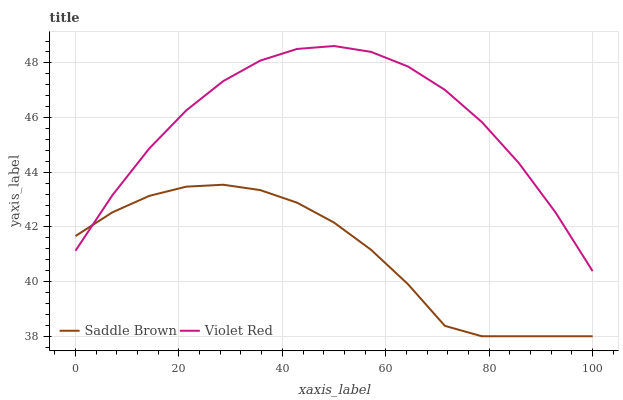Does Saddle Brown have the minimum area under the curve?
Answer yes or no. Yes. Does Violet Red have the maximum area under the curve?
Answer yes or no. Yes. Does Saddle Brown have the maximum area under the curve?
Answer yes or no. No. Is Saddle Brown the smoothest?
Answer yes or no. Yes. Is Violet Red the roughest?
Answer yes or no. Yes. Is Saddle Brown the roughest?
Answer yes or no. No. Does Saddle Brown have the lowest value?
Answer yes or no. Yes. Does Violet Red have the highest value?
Answer yes or no. Yes. Does Saddle Brown have the highest value?
Answer yes or no. No. Does Saddle Brown intersect Violet Red?
Answer yes or no. Yes. Is Saddle Brown less than Violet Red?
Answer yes or no. No. Is Saddle Brown greater than Violet Red?
Answer yes or no. No. 